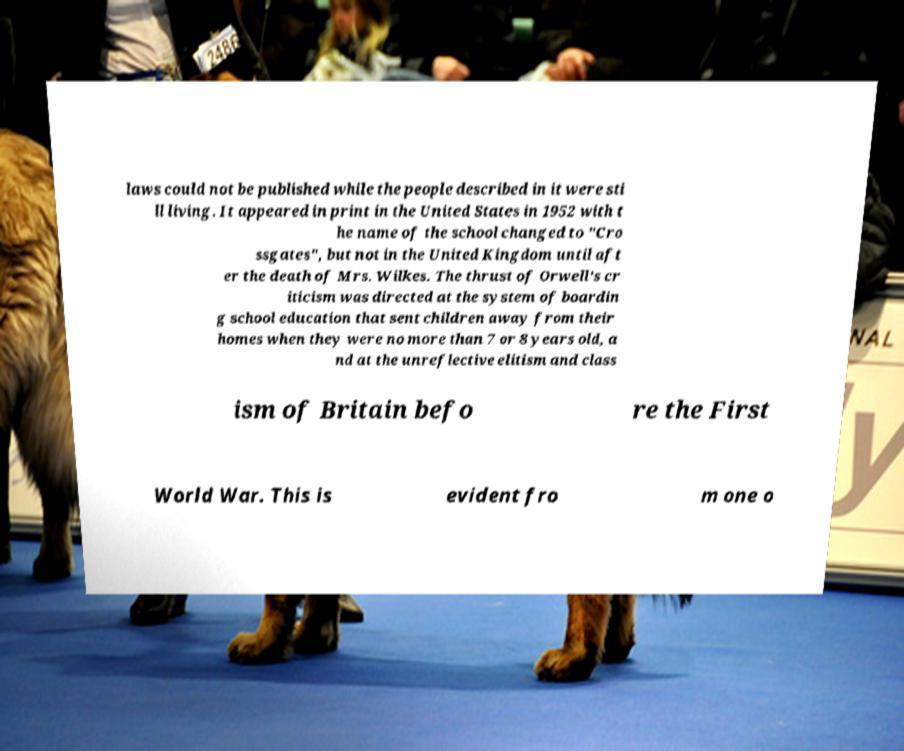There's text embedded in this image that I need extracted. Can you transcribe it verbatim? laws could not be published while the people described in it were sti ll living. It appeared in print in the United States in 1952 with t he name of the school changed to "Cro ssgates", but not in the United Kingdom until aft er the death of Mrs. Wilkes. The thrust of Orwell's cr iticism was directed at the system of boardin g school education that sent children away from their homes when they were no more than 7 or 8 years old, a nd at the unreflective elitism and class ism of Britain befo re the First World War. This is evident fro m one o 